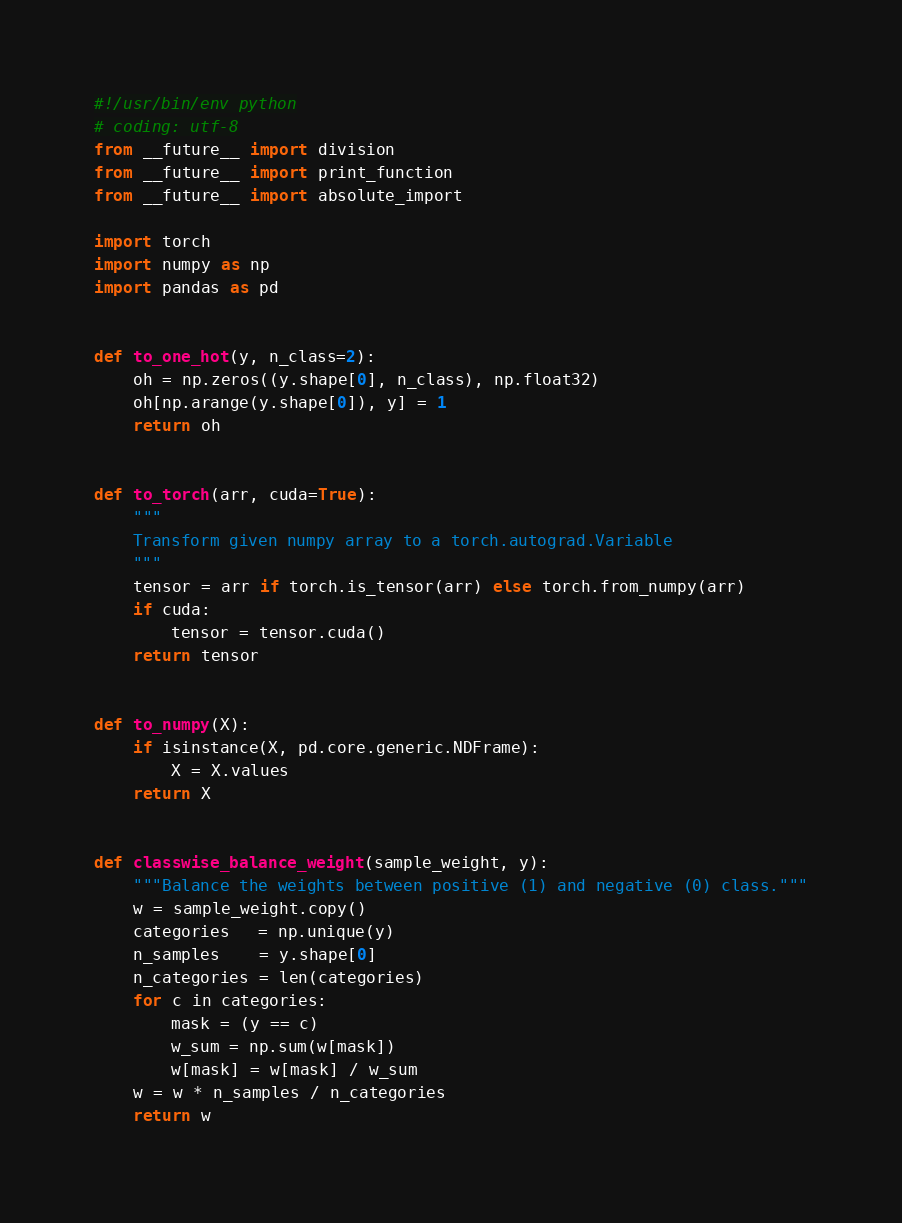Convert code to text. <code><loc_0><loc_0><loc_500><loc_500><_Python_>#!/usr/bin/env python
# coding: utf-8
from __future__ import division
from __future__ import print_function
from __future__ import absolute_import

import torch
import numpy as np
import pandas as pd


def to_one_hot(y, n_class=2):
    oh = np.zeros((y.shape[0], n_class), np.float32)
    oh[np.arange(y.shape[0]), y] = 1
    return oh


def to_torch(arr, cuda=True):
    """
    Transform given numpy array to a torch.autograd.Variable
    """
    tensor = arr if torch.is_tensor(arr) else torch.from_numpy(arr)
    if cuda:
        tensor = tensor.cuda()
    return tensor


def to_numpy(X):
    if isinstance(X, pd.core.generic.NDFrame):
        X = X.values
    return X


def classwise_balance_weight(sample_weight, y):
    """Balance the weights between positive (1) and negative (0) class."""
    w = sample_weight.copy()
    categories   = np.unique(y)
    n_samples    = y.shape[0]
    n_categories = len(categories)
    for c in categories:
        mask = (y == c)
        w_sum = np.sum(w[mask])
        w[mask] = w[mask] / w_sum
    w = w * n_samples / n_categories
    return w
</code> 